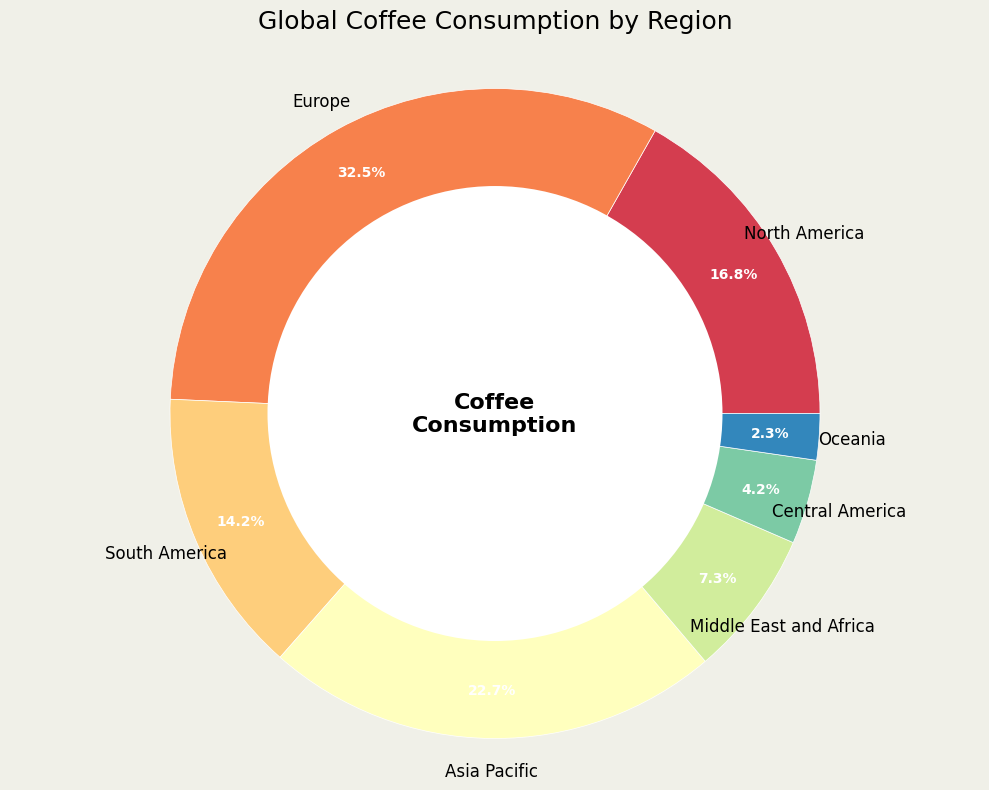Which region has the highest coffee consumption percentage? The figure shows different regions with their respective coffee consumption percentages. Europe has the highest percentage, which is reflected by the largest wedge in the ring chart.
Answer: Europe What's the combined coffee consumption percentage of North America and Europe? From the figure, North America has a consumption percentage of 16.8%, and Europe has 32.5%. Adding them gives 16.8% + 32.5% = 49.3%.
Answer: 49.3% What is the difference in coffee consumption percentage between South America and Asia Pacific? The figure shows South America's consumption percentage at 14.2% and Asia Pacific's at 22.7%. Subtracting these gives 22.7% - 14.2% = 8.5%.
Answer: 8.5% Which regions have a coffee consumption percentage less than 10%? The figure shows the consumption percentages of various regions. The regions with less than 10% are the Middle East and Africa (7.3%), Central America (4.2%), and Oceania (2.3%).
Answer: Middle East and Africa, Central America, Oceania What's the average coffee consumption percentage of South America, Central America, and Oceania? The figure gives the consumption percentages for South America (14.2%), Central America (4.2%), and Oceania (2.3%). Adding these gives 14.2% + 4.2% + 2.3% = 20.7%. Dividing by 3 gives 20.7% / 3 = 6.9%.
Answer: 6.9% How much higher is Europe's consumption percentage compared to the Middle East and Africa's? According to the chart, Europe has a consumption percentage of 32.5%, and the Middle East and Africa has 7.3%. The difference is 32.5% - 7.3% = 25.2%.
Answer: 25.2% Which region's wedge is closest in color to blue? In the ring chart, the colors range across the spectrum. The wedge closest to the blue spectrum appears to be Oceania.
Answer: Oceania Among the regions with consumption percentages above 20%, which has the second highest percentage? The regions with above 20% are Europe (32.5%) and Asia Pacific (22.7%). Asia Pacific has the second highest percentage after Europe.
Answer: Asia Pacific If we combine Central America's and Oceania's consumption percentages, do they exceed the percentage of South America? The figure shows Central America's percentage is 4.2% and Oceania's is 2.3%, making a combined total of 4.2% + 2.3% = 6.5%. South America's consumption is 14.2%, so 6.5% does not exceed 14.2%.
Answer: No 